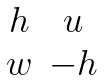<formula> <loc_0><loc_0><loc_500><loc_500>\begin{matrix} h & u \\ w & - h \end{matrix}</formula> 